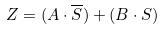Convert formula to latex. <formula><loc_0><loc_0><loc_500><loc_500>Z = ( A \cdot \overline { S } ) + ( B \cdot S )</formula> 